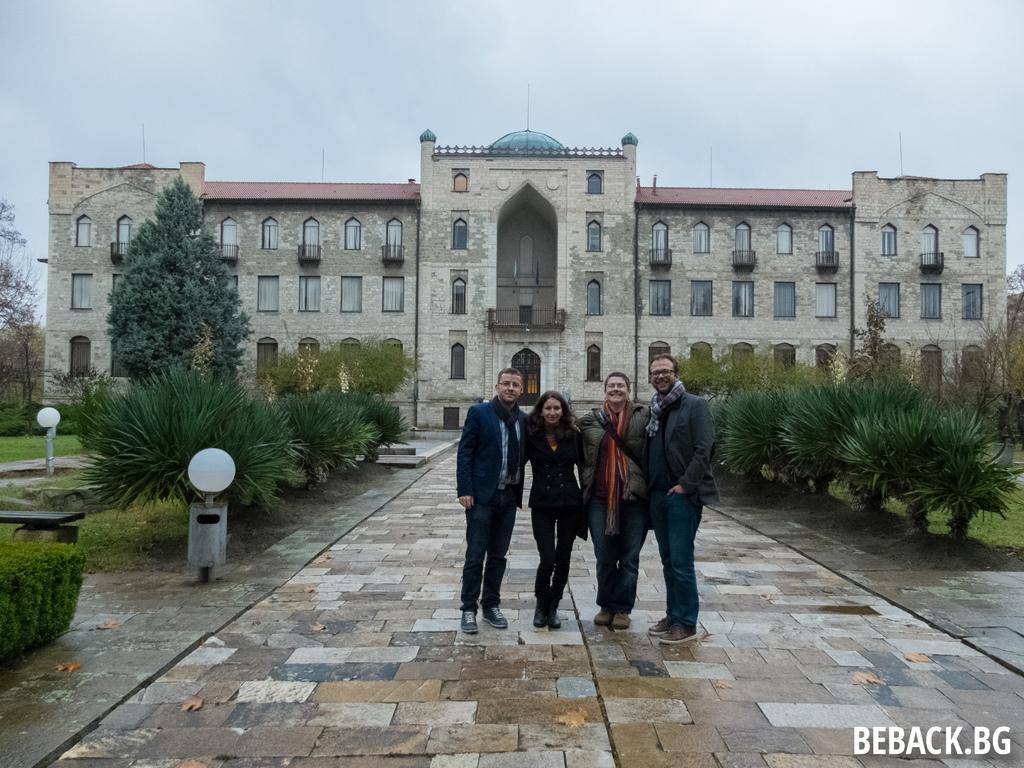Describe this image in one or two sentences. In this image we can group of persons standing on the ground. To the left side of the image we can see some light poles, a bench placed on the ground. In the background, we can see group of plants, trees, building with windows, railings and the sky. 